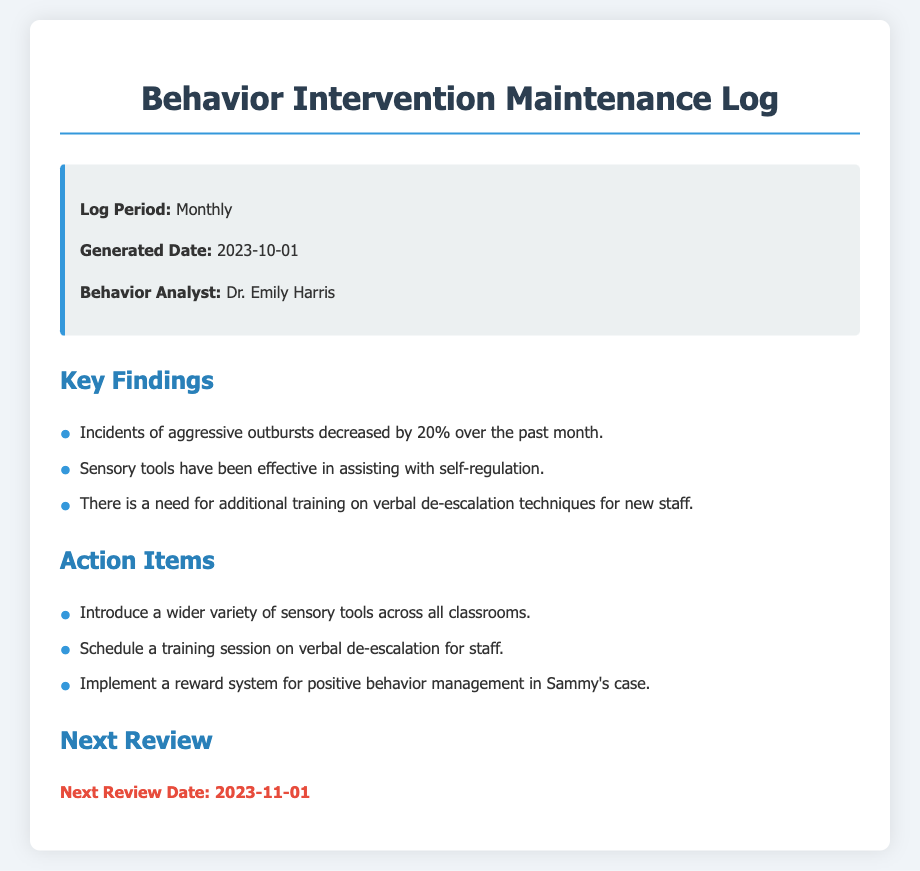What is the log period? The log period is specified in the document and indicates how often the log is generated, which is monthly.
Answer: Monthly Who is the behavior analyst? The document lists the name of the behavior analyst who generated the log, which is Dr. Emily Harris.
Answer: Dr. Emily Harris What percentage did incidents of aggressive outbursts decrease? The document provides specific data regarding behavioral incidents, indicating a 20% decrease in aggressive outbursts.
Answer: 20% What is one of the key findings about sensory tools? The document notes the effectiveness of sensory tools in managing behavior, specifically mentioning their role in self-regulation.
Answer: Effective in assisting with self-regulation What is scheduled for staff training? The action items section mentions that there is a scheduled training session focusing on verbal de-escalation techniques.
Answer: Verbal de-escalation techniques What is the next review date? The document clearly states when the next review is planned, which is on November 1, 2023.
Answer: 2023-11-01 What action item focuses on Sammy's case? The action items include a specific strategy regarding Sammy that involves a reward system for positive behavior management.
Answer: Implement a reward system for positive behavior management in Sammy's case How are sensory tools recommended to be utilized? The document recommends introducing a wider variety of sensory tools across all classrooms to enhance behavioral interventions.
Answer: Introduce a wider variety of sensory tools across all classrooms 